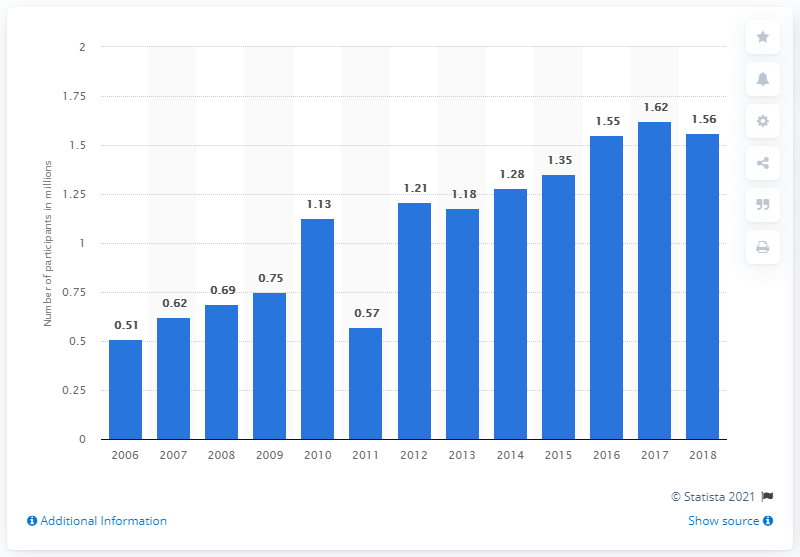Outline some significant characteristics in this image. In 2018, the total number of participants in rugby in the United States was 1.56 million. 